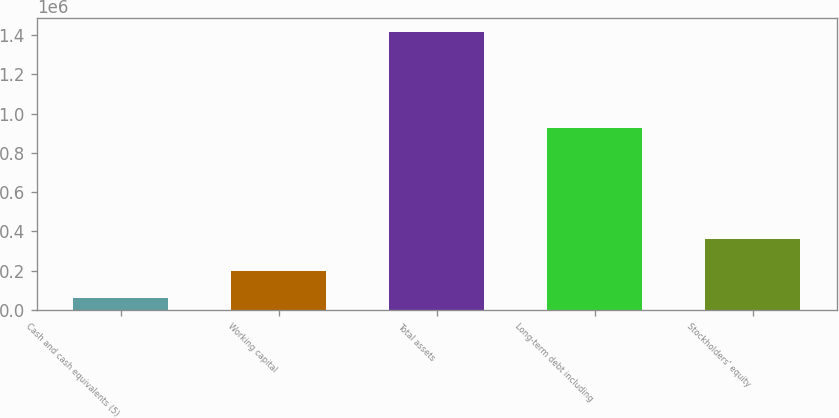Convert chart to OTSL. <chart><loc_0><loc_0><loc_500><loc_500><bar_chart><fcel>Cash and cash equivalents (5)<fcel>Working capital<fcel>Total assets<fcel>Long-term debt including<fcel>Stockholders' equity<nl><fcel>61217<fcel>196766<fcel>1.41671e+06<fcel>925000<fcel>363041<nl></chart> 